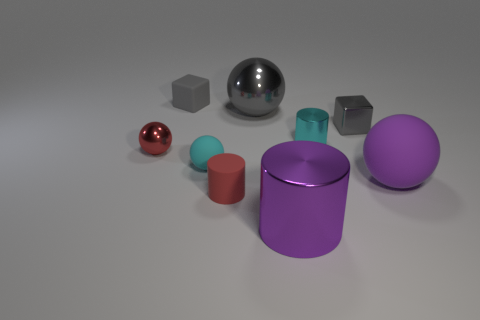Does the tiny shiny thing that is in front of the small cyan shiny object have the same shape as the cyan matte object?
Your answer should be compact. Yes. The other rubber thing that is the same shape as the big rubber thing is what color?
Your answer should be very brief. Cyan. Are there an equal number of large metal things behind the tiny cyan matte ball and tiny gray blocks?
Keep it short and to the point. No. How many things are to the right of the red metal object and on the left side of the big purple metal cylinder?
Your response must be concise. 4. What size is the cyan thing that is the same shape as the red shiny object?
Offer a terse response. Small. How many small objects have the same material as the cyan cylinder?
Keep it short and to the point. 2. Is the number of metal things that are in front of the tiny metal cylinder less than the number of tiny green things?
Offer a terse response. No. What number of tiny spheres are there?
Your answer should be very brief. 2. What number of other blocks have the same color as the small rubber block?
Ensure brevity in your answer.  1. Does the large gray object have the same shape as the small gray matte thing?
Provide a succinct answer. No. 